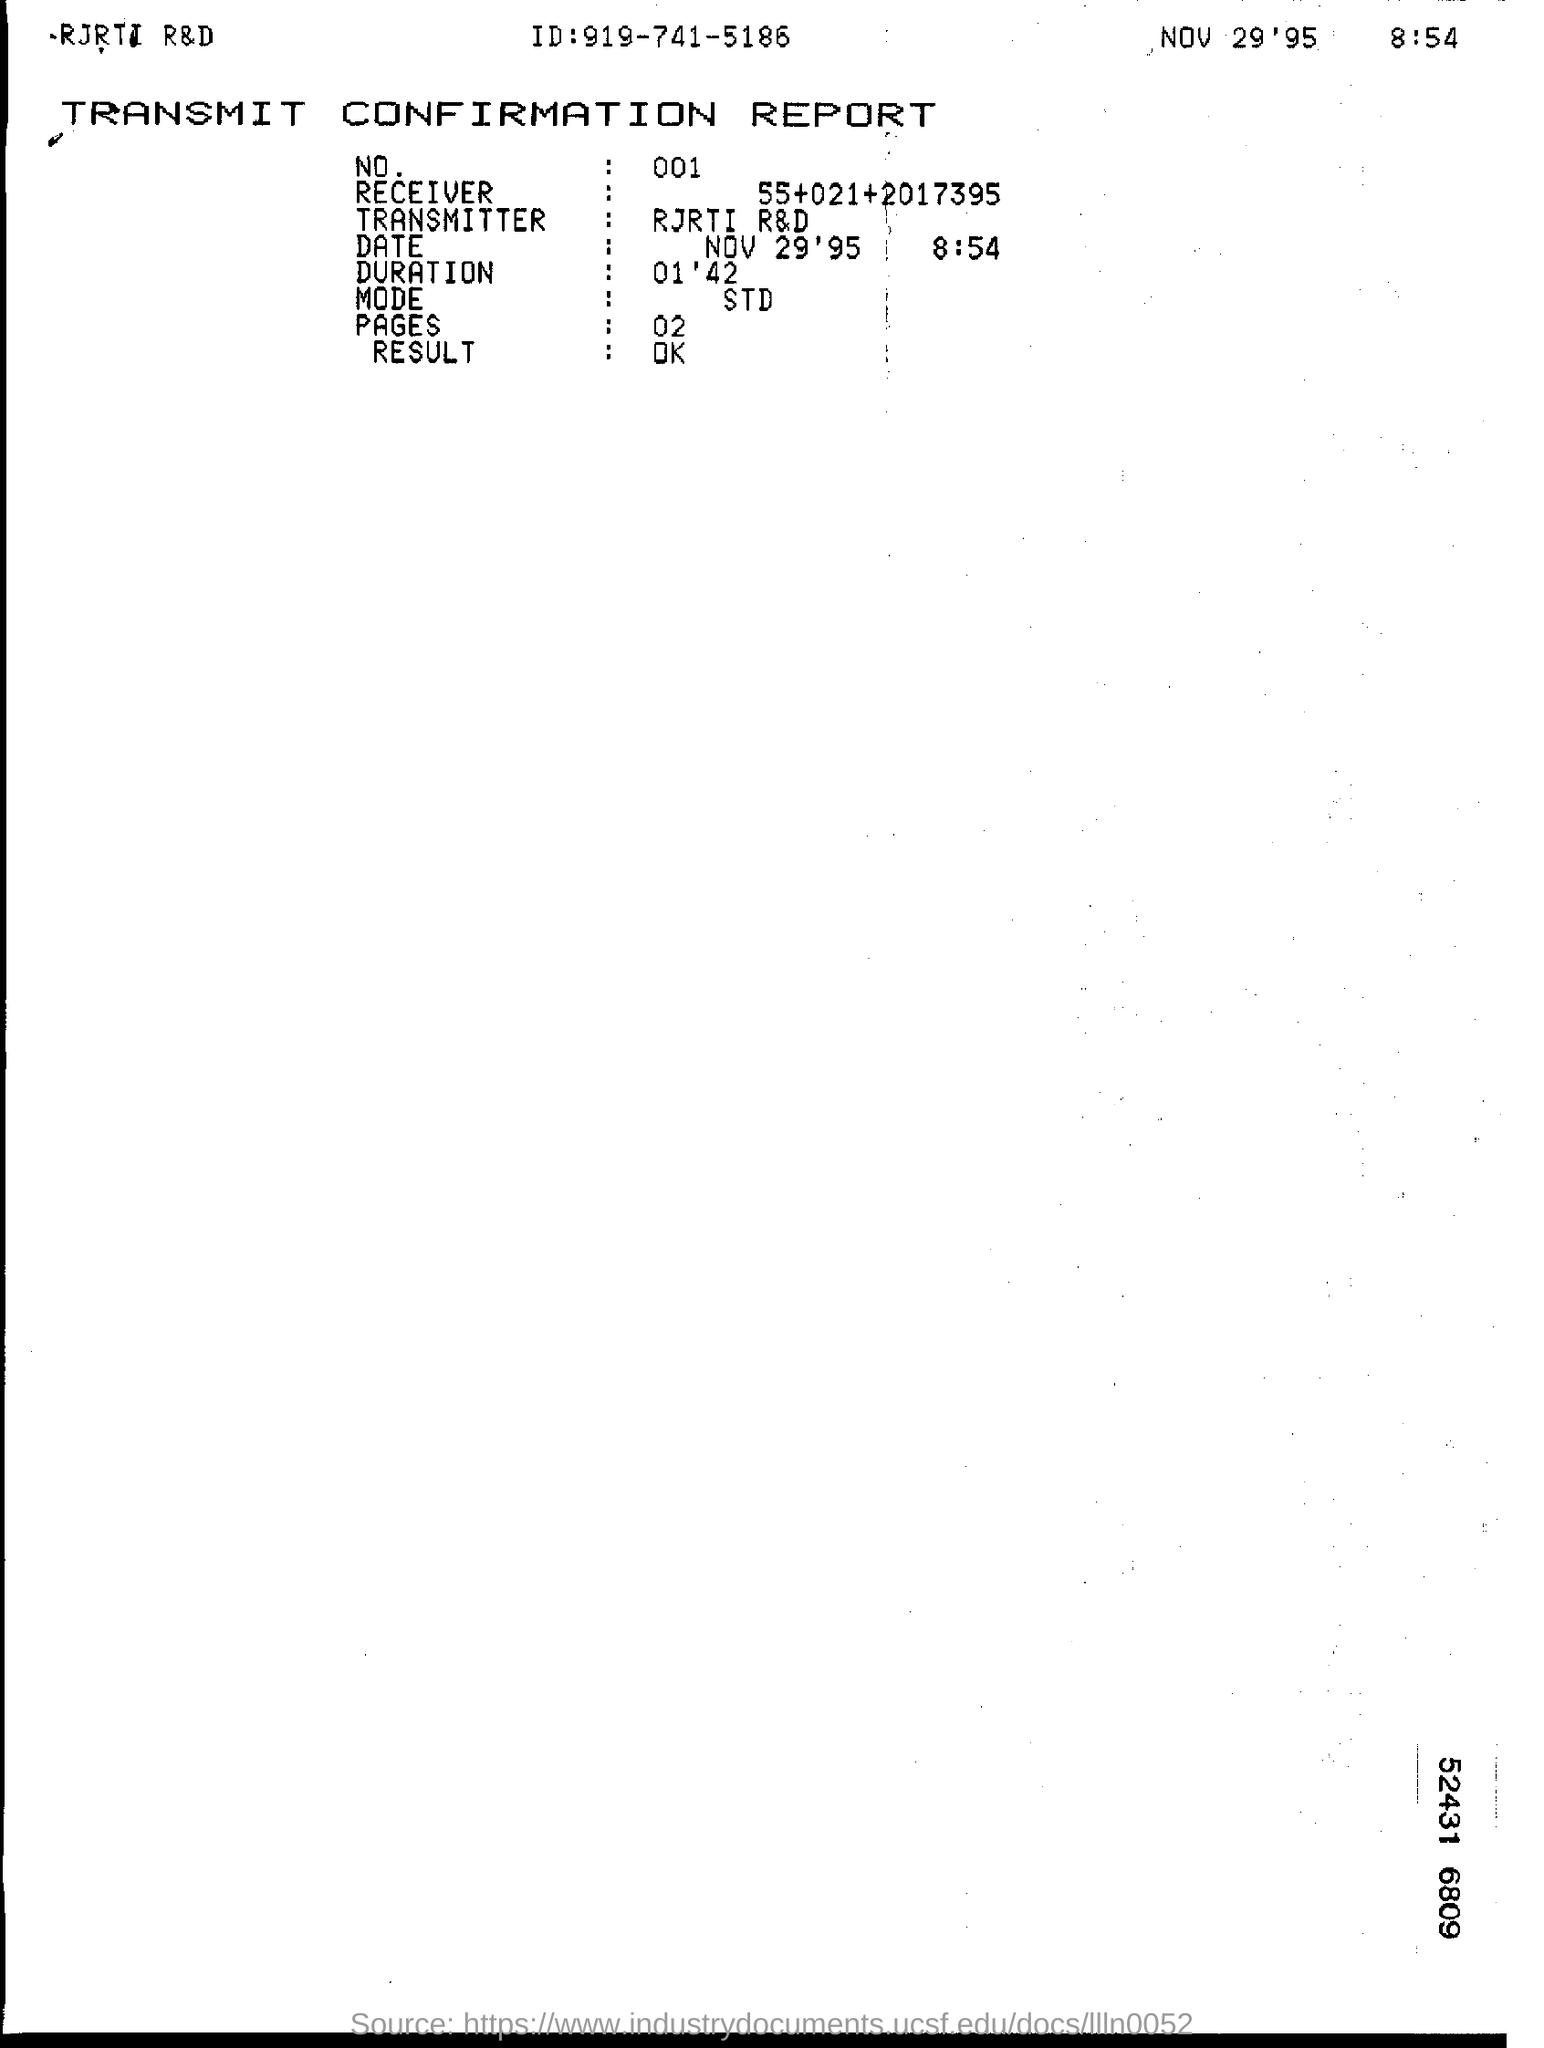Who is the Transmitter?
Offer a very short reply. RJRTI R&D. What is the Duration?
Give a very brief answer. 01'42. What is the Mode?
Keep it short and to the point. STD. What is the Result?
Your answer should be very brief. Ok. What is the NO.?
Keep it short and to the point. 001. How many Pages?
Provide a short and direct response. 02. 